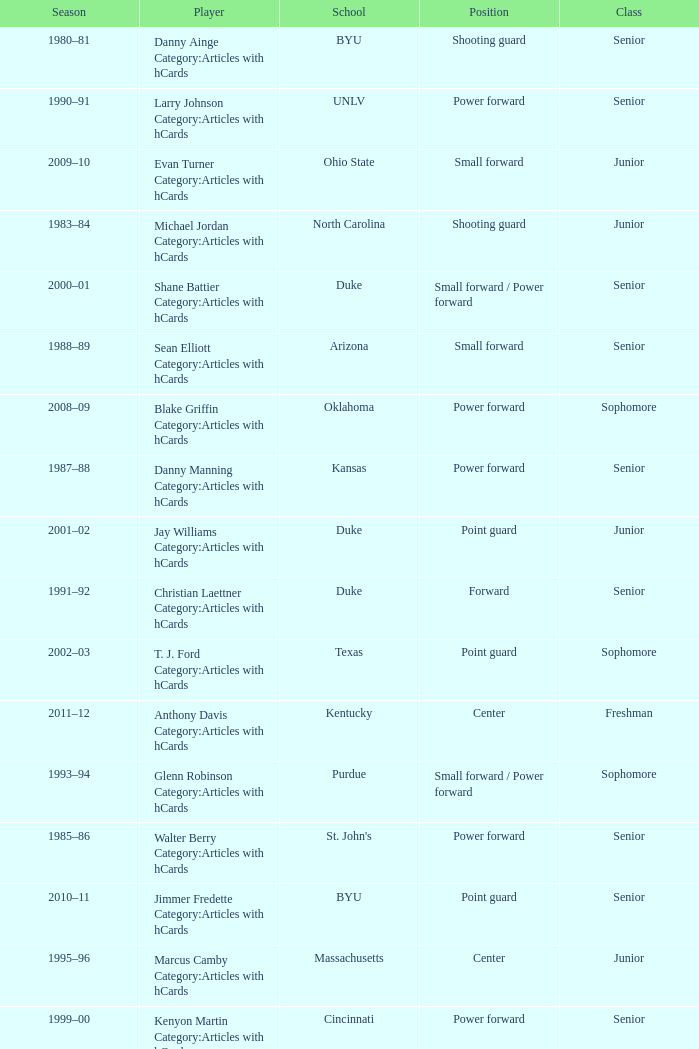Name the position for indiana state Small forward. 